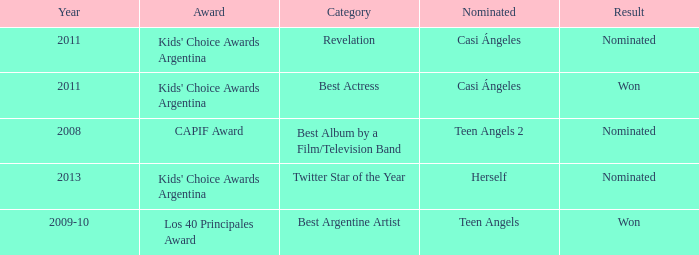Name the performance nominated for a Capif Award. Teen Angels 2. 